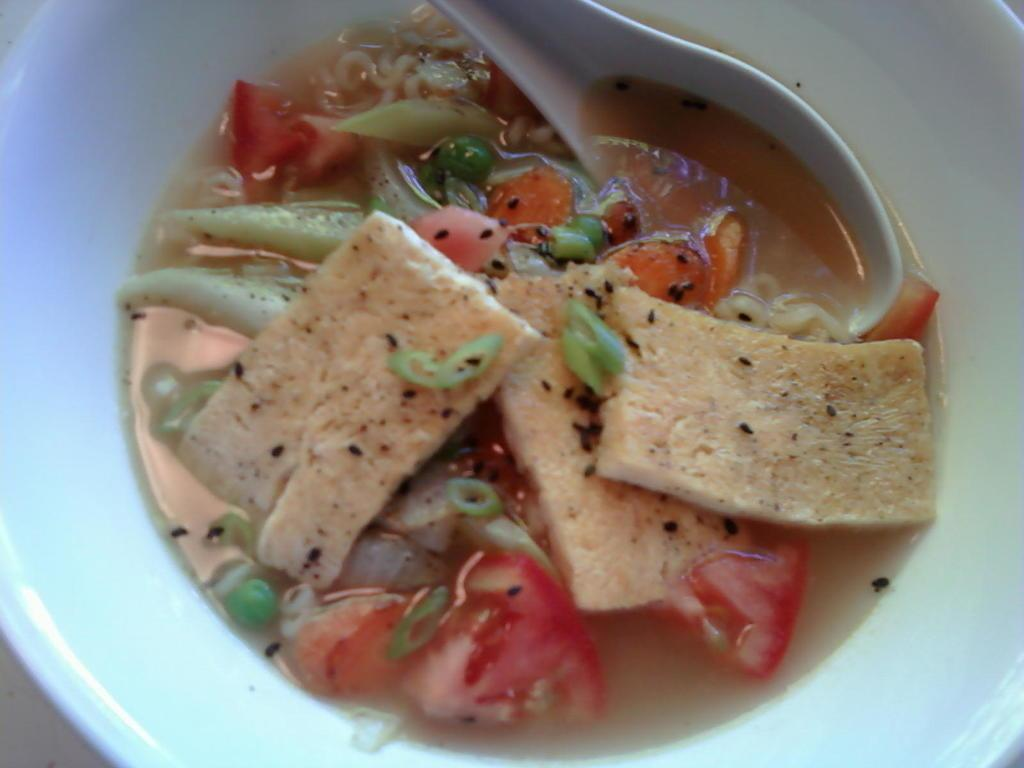What is in the bowl in the image? There is a food item in the bowl. What utensil is present in the bowl? There is a spoon in the bowl. What type of chickens can be seen wearing a shirt in the image? There are no chickens or shirts present in the image. 